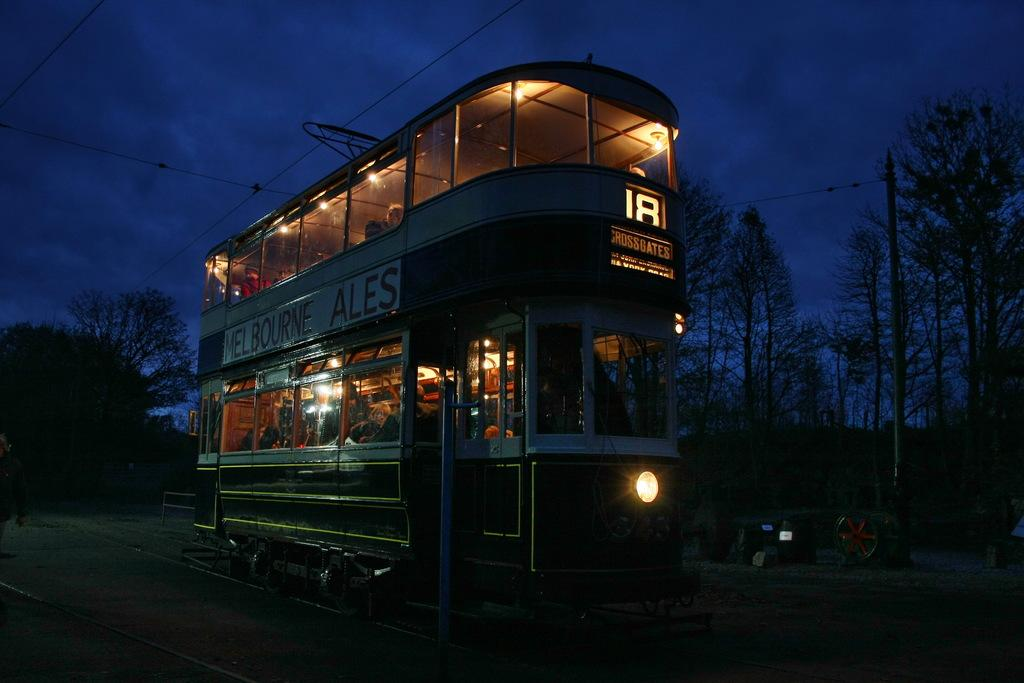What is the main subject in the center of the image? There is a Double Decker bus in the center of the image. What can be seen in the background of the image? There are trees in the background of the image. What is visible at the top of the image? The sky is visible at the top of the image. How much money is being exchanged between the passengers on the Double Decker bus in the image? There is no indication of money exchange or passengers in the image; it only features a Double Decker bus. What type of cabbage is growing on the trees in the background of the image? There are no cabbages present in the image; the trees in the background are not specified as being cabbage trees. 